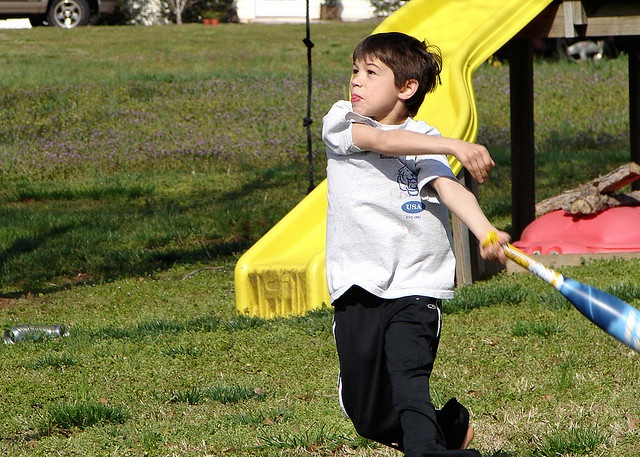Describe the objects in this image and their specific colors. I can see people in black, white, tan, and gray tones, baseball bat in black, white, olive, lightblue, and blue tones, and car in black, gray, olive, and darkgray tones in this image. 